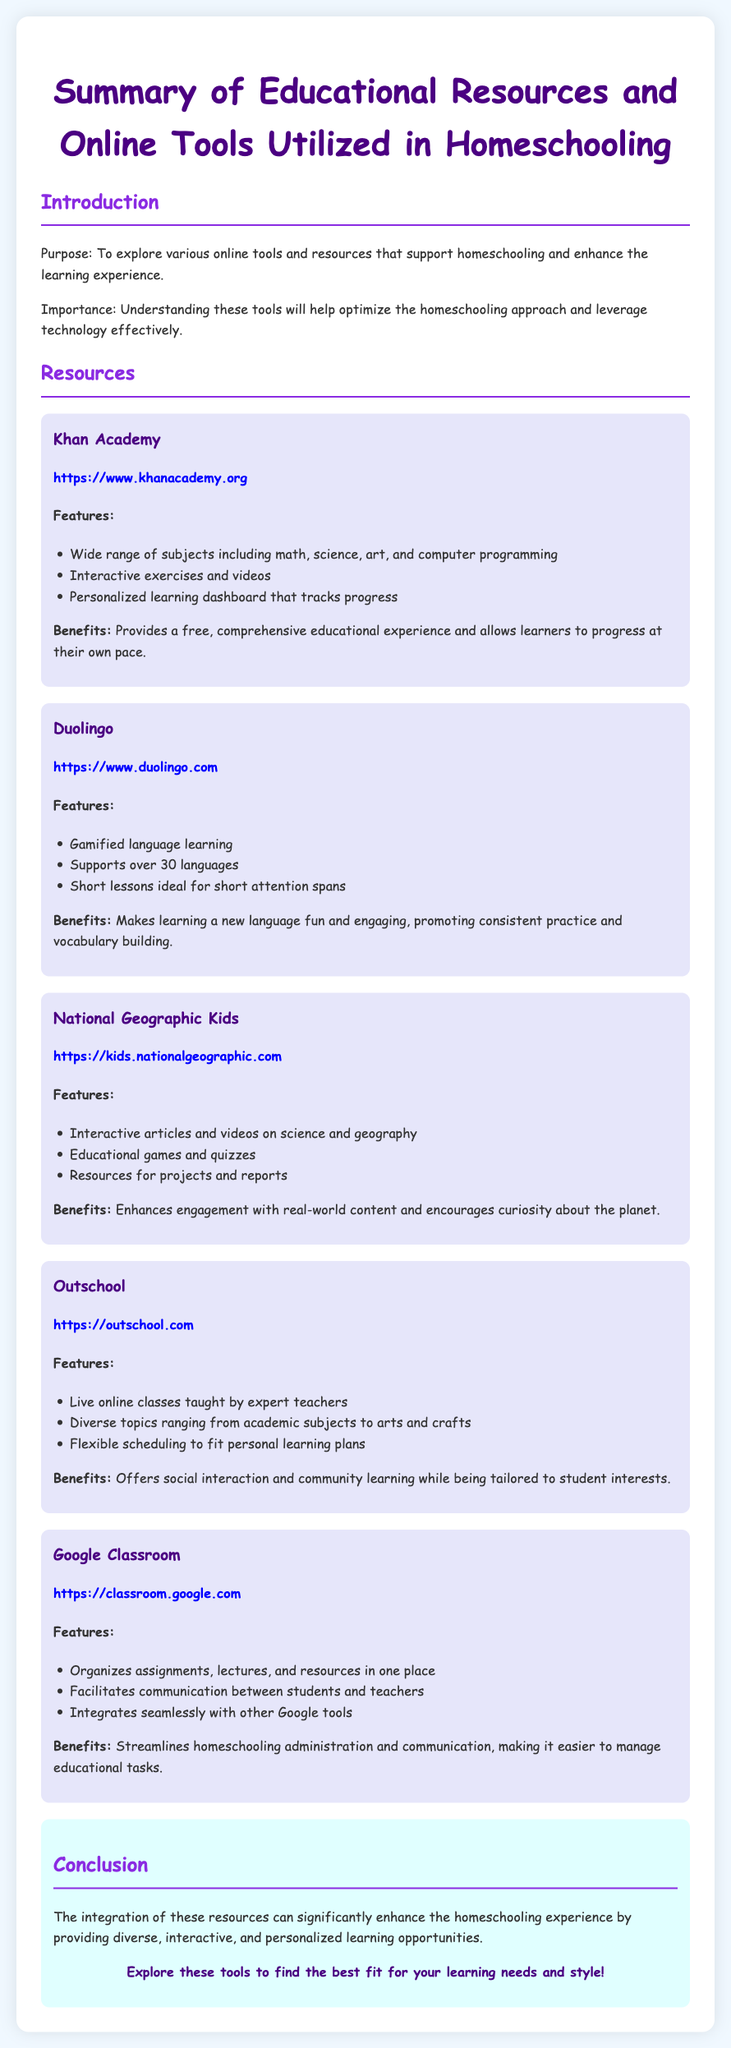What is the purpose of the document? The purpose is to explore various online tools and resources that support homeschooling and enhance the learning experience.
Answer: To explore various online tools and resources How many resources are listed in the document? The document lists five educational resources.
Answer: Five What online tool provides a personalized learning dashboard? The tool that provides this feature is mentioned as having that option in its description.
Answer: Khan Academy Which platform supports over 30 languages? This platform is characterized by its language learning capabilities in the document.
Answer: Duolingo What type of classes does Outschool offer? The document specifies the type of classes available on this platform.
Answer: Live online classes What feature allows for communication between students and teachers? This feature is highlighted as part of one of the resources in the document.
Answer: Google Classroom What is the main benefit of National Geographic Kids? The benefit mentioned in relation to engagement and curiosity is noted in the document.
Answer: Enhances engagement with real-world content Name one educational game feature mentioned in the document. The document references specific types of engaging media offered by one platform.
Answer: Educational games and quizzes 